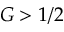Convert formula to latex. <formula><loc_0><loc_0><loc_500><loc_500>G > 1 / 2</formula> 